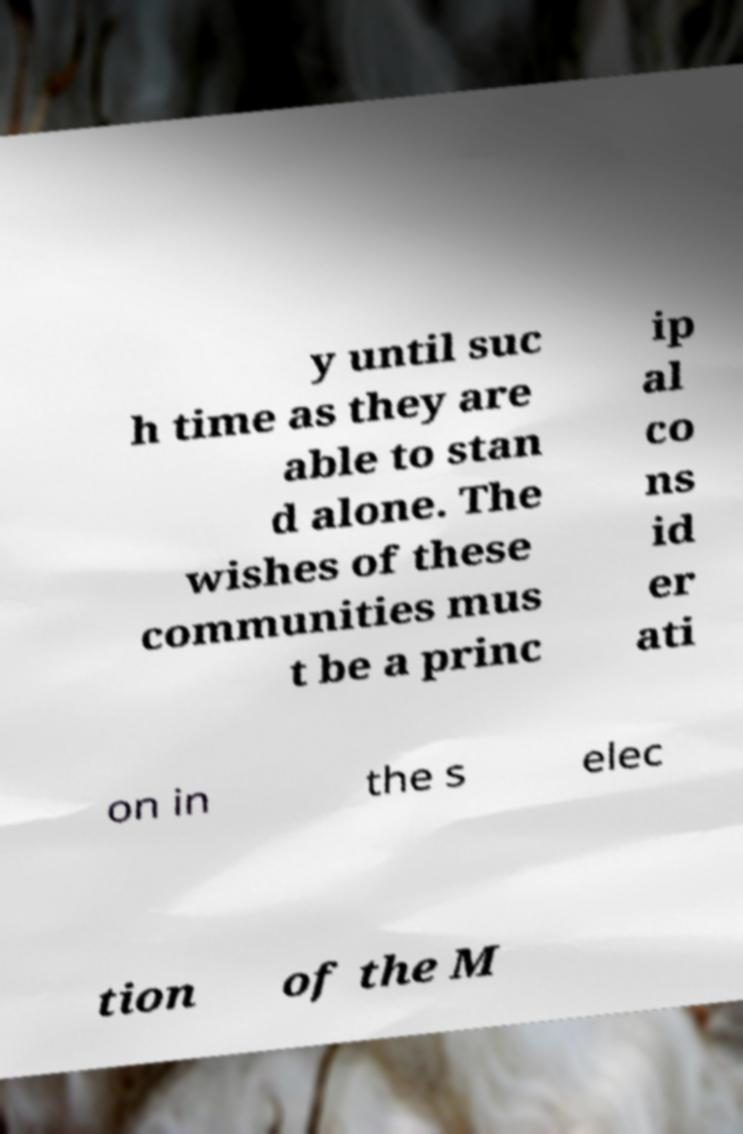What messages or text are displayed in this image? I need them in a readable, typed format. y until suc h time as they are able to stan d alone. The wishes of these communities mus t be a princ ip al co ns id er ati on in the s elec tion of the M 